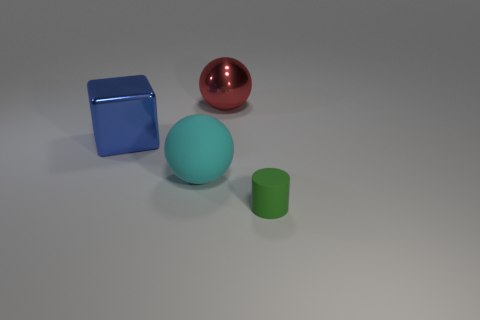Add 4 gray things. How many objects exist? 8 Subtract all red balls. How many balls are left? 1 Subtract all cylinders. How many objects are left? 3 Subtract 0 cyan cylinders. How many objects are left? 4 Subtract all gray cubes. Subtract all green spheres. How many cubes are left? 1 Subtract all yellow balls. Subtract all green things. How many objects are left? 3 Add 2 large cyan matte things. How many large cyan matte things are left? 3 Add 2 large cyan rubber things. How many large cyan rubber things exist? 3 